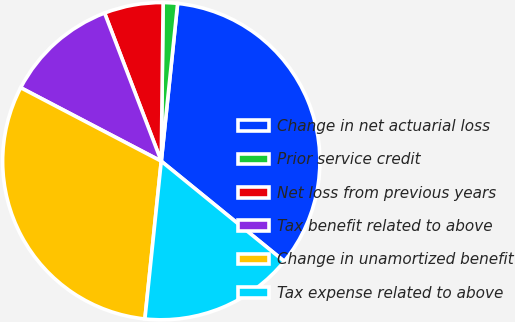Convert chart. <chart><loc_0><loc_0><loc_500><loc_500><pie_chart><fcel>Change in net actuarial loss<fcel>Prior service credit<fcel>Net loss from previous years<fcel>Tax benefit related to above<fcel>Change in unamortized benefit<fcel>Tax expense related to above<nl><fcel>34.23%<fcel>1.46%<fcel>6.0%<fcel>11.52%<fcel>31.02%<fcel>15.77%<nl></chart> 